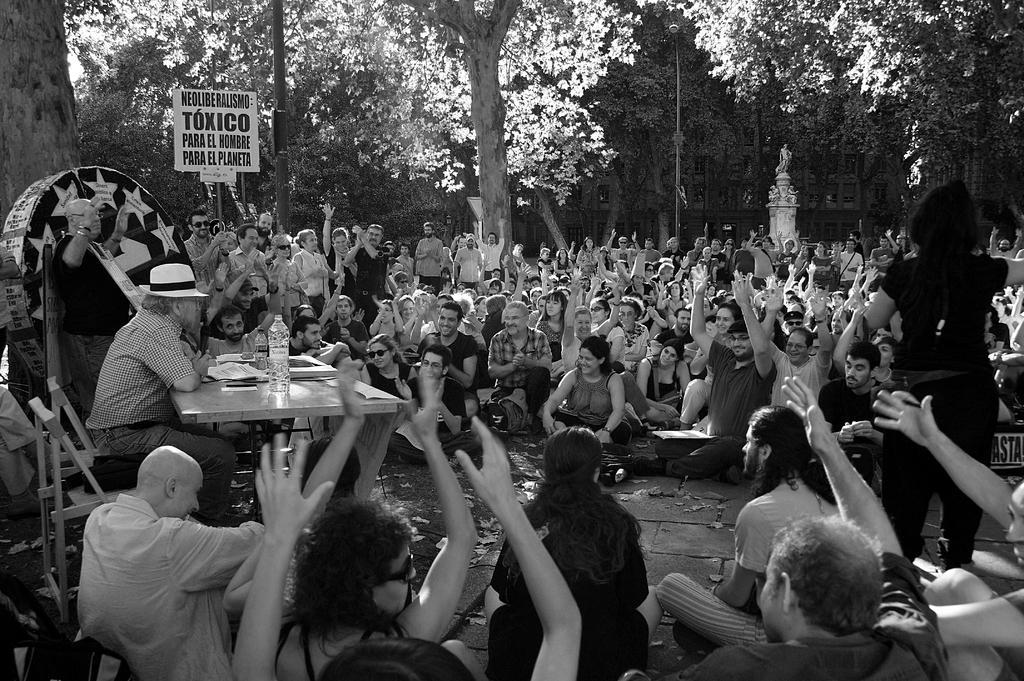Could you give a brief overview of what you see in this image? This is a black and white image. These are the trees with branches and leaves. This looks like a pole. This is the man sitting on the chair. I can see a table with papers and water bottles on it. There are group of people sitting and standing. This looks like a board. I think this is a sculpture. In the background, that looks like a building. 